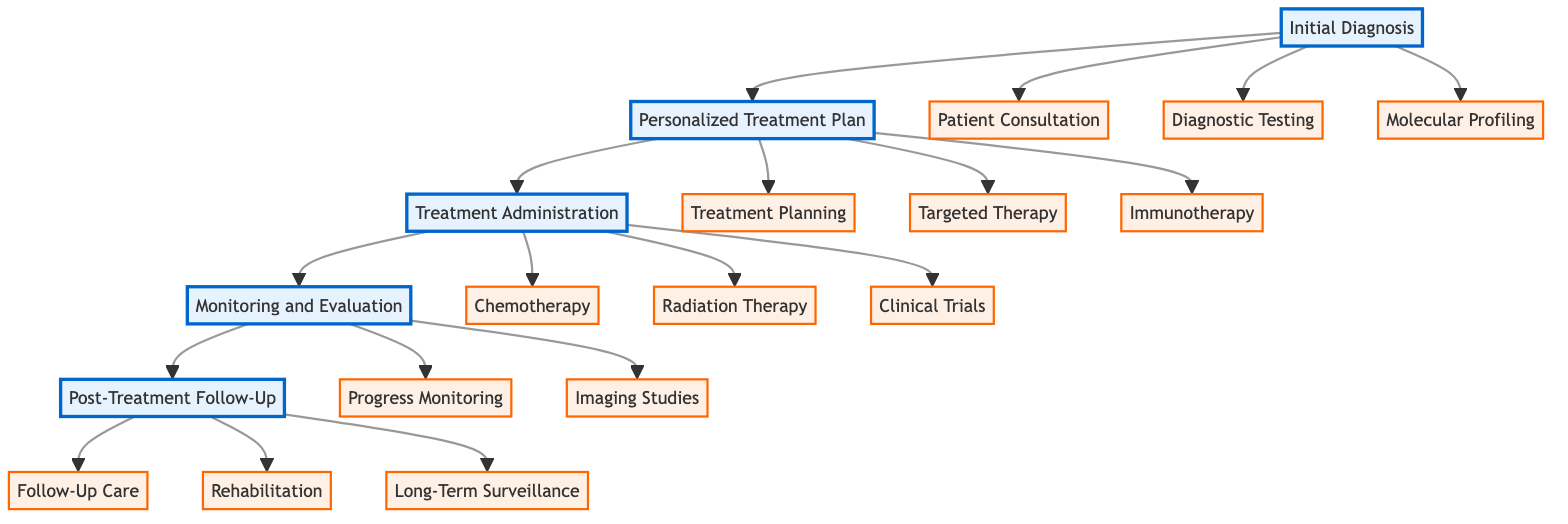What is the first step in the clinical pathway? The clinical pathway begins with the "Initial Diagnosis", indicating that this is the starting point for the personalized medicine process.
Answer: Initial Diagnosis How many types of diagnostic testing are listed? The diagram lists three types of diagnostic testing under "Initial Diagnosis": genomic sequencing, MRI scan, and CT scan. Therefore, the number of testing types is counted directly from those listed.
Answer: 3 Which hospital conducts the chemotherapy administration? According to the diagram, chemotherapy is administered at Guy's Cancer Centre, revealing the specific location for this treatment step.
Answer: Guy's Cancer Centre What is the focus of the "Personalized Treatment Plan"? The "Personalized Treatment Plan" focuses on developing a unique treatment strategy that includes input from a multidisciplinary team, alongside the specific therapy types. This indicates its primary function in the pathway relates to tailoring treatments to individual patient needs.
Answer: Targeted Therapy Which type of imaging studies occurs bi-annually? The diagram indicates that MRI scans are performed bi-annually under "Monitoring and Evaluation", specifying this particular frequency for monitoring patient progress post-treatment.
Answer: MRI scans What is the purpose of the "Long-Term Surveillance" step? The "Long-Term Surveillance" step involves yearly genomic surveillance at the Wellcome Sanger Institute, suggesting it is designed to monitor for any potential recurrence or new developments in the patient's cancer over time.
Answer: Yearly genomic surveillance What is the main objective of the "Progress Monitoring"? The main objective of "Progress Monitoring" involves conducting monthly blood tests, indicating its role in continuously assessing the patient's response to treatment during the "Monitoring and Evaluation" phase.
Answer: Monthly blood tests How many main phases are there in the clinical pathway? There are five main phases in the clinical pathway: Initial Diagnosis, Personalized Treatment Plan, Treatment Administration, Monitoring and Evaluation, and Post-Treatment Follow-Up, which can be determined by counting the main nodes in the flow.
Answer: 5 